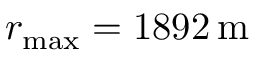Convert formula to latex. <formula><loc_0><loc_0><loc_500><loc_500>r _ { \max } = 1 8 9 2 \, m</formula> 